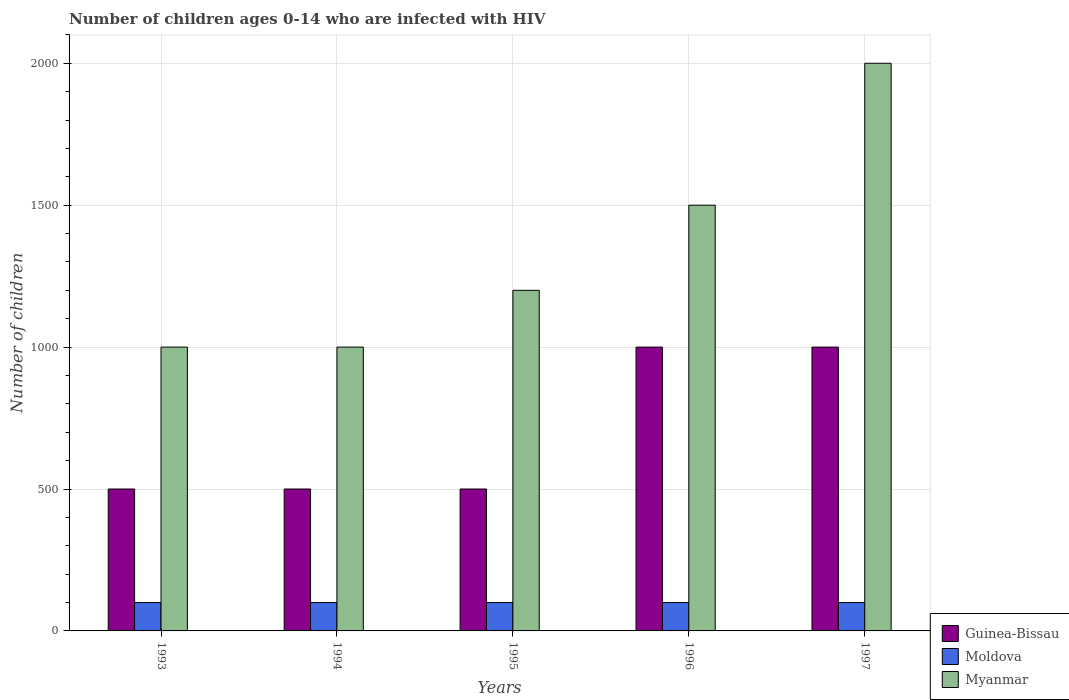How many bars are there on the 2nd tick from the left?
Provide a succinct answer. 3. What is the label of the 5th group of bars from the left?
Your answer should be compact. 1997. What is the number of HIV infected children in Guinea-Bissau in 1994?
Ensure brevity in your answer.  500. Across all years, what is the maximum number of HIV infected children in Moldova?
Offer a terse response. 100. Across all years, what is the minimum number of HIV infected children in Myanmar?
Your answer should be very brief. 1000. In which year was the number of HIV infected children in Moldova minimum?
Offer a very short reply. 1993. What is the total number of HIV infected children in Guinea-Bissau in the graph?
Your response must be concise. 3500. What is the difference between the number of HIV infected children in Myanmar in 1994 and that in 1995?
Provide a succinct answer. -200. What is the difference between the number of HIV infected children in Guinea-Bissau in 1994 and the number of HIV infected children in Moldova in 1995?
Your answer should be very brief. 400. What is the average number of HIV infected children in Guinea-Bissau per year?
Offer a very short reply. 700. In the year 1993, what is the difference between the number of HIV infected children in Myanmar and number of HIV infected children in Moldova?
Your response must be concise. 900. In how many years, is the number of HIV infected children in Guinea-Bissau greater than 1700?
Offer a very short reply. 0. What is the ratio of the number of HIV infected children in Myanmar in 1993 to that in 1995?
Keep it short and to the point. 0.83. Is the difference between the number of HIV infected children in Myanmar in 1995 and 1996 greater than the difference between the number of HIV infected children in Moldova in 1995 and 1996?
Offer a very short reply. No. What is the difference between the highest and the lowest number of HIV infected children in Myanmar?
Your answer should be very brief. 1000. In how many years, is the number of HIV infected children in Myanmar greater than the average number of HIV infected children in Myanmar taken over all years?
Provide a succinct answer. 2. Is the sum of the number of HIV infected children in Guinea-Bissau in 1994 and 1996 greater than the maximum number of HIV infected children in Myanmar across all years?
Offer a very short reply. No. What does the 2nd bar from the left in 1996 represents?
Provide a short and direct response. Moldova. What does the 2nd bar from the right in 1993 represents?
Offer a very short reply. Moldova. How many bars are there?
Your answer should be very brief. 15. Are all the bars in the graph horizontal?
Your answer should be compact. No. Are the values on the major ticks of Y-axis written in scientific E-notation?
Your answer should be very brief. No. Where does the legend appear in the graph?
Offer a terse response. Bottom right. How are the legend labels stacked?
Your response must be concise. Vertical. What is the title of the graph?
Your answer should be compact. Number of children ages 0-14 who are infected with HIV. Does "Liberia" appear as one of the legend labels in the graph?
Keep it short and to the point. No. What is the label or title of the Y-axis?
Ensure brevity in your answer.  Number of children. What is the Number of children of Guinea-Bissau in 1993?
Offer a terse response. 500. What is the Number of children of Myanmar in 1993?
Offer a terse response. 1000. What is the Number of children of Moldova in 1994?
Offer a very short reply. 100. What is the Number of children of Myanmar in 1995?
Provide a short and direct response. 1200. What is the Number of children in Guinea-Bissau in 1996?
Your response must be concise. 1000. What is the Number of children of Moldova in 1996?
Give a very brief answer. 100. What is the Number of children in Myanmar in 1996?
Make the answer very short. 1500. What is the Number of children of Guinea-Bissau in 1997?
Make the answer very short. 1000. What is the Number of children of Myanmar in 1997?
Your response must be concise. 2000. Across all years, what is the maximum Number of children of Guinea-Bissau?
Give a very brief answer. 1000. Across all years, what is the maximum Number of children in Moldova?
Provide a short and direct response. 100. Across all years, what is the maximum Number of children of Myanmar?
Make the answer very short. 2000. What is the total Number of children of Guinea-Bissau in the graph?
Your answer should be compact. 3500. What is the total Number of children in Moldova in the graph?
Ensure brevity in your answer.  500. What is the total Number of children of Myanmar in the graph?
Provide a succinct answer. 6700. What is the difference between the Number of children of Guinea-Bissau in 1993 and that in 1994?
Give a very brief answer. 0. What is the difference between the Number of children of Moldova in 1993 and that in 1994?
Provide a succinct answer. 0. What is the difference between the Number of children of Myanmar in 1993 and that in 1994?
Offer a very short reply. 0. What is the difference between the Number of children of Guinea-Bissau in 1993 and that in 1995?
Ensure brevity in your answer.  0. What is the difference between the Number of children in Moldova in 1993 and that in 1995?
Your answer should be very brief. 0. What is the difference between the Number of children in Myanmar in 1993 and that in 1995?
Your answer should be very brief. -200. What is the difference between the Number of children of Guinea-Bissau in 1993 and that in 1996?
Provide a succinct answer. -500. What is the difference between the Number of children in Myanmar in 1993 and that in 1996?
Offer a terse response. -500. What is the difference between the Number of children in Guinea-Bissau in 1993 and that in 1997?
Offer a terse response. -500. What is the difference between the Number of children of Myanmar in 1993 and that in 1997?
Your response must be concise. -1000. What is the difference between the Number of children of Moldova in 1994 and that in 1995?
Give a very brief answer. 0. What is the difference between the Number of children of Myanmar in 1994 and that in 1995?
Provide a short and direct response. -200. What is the difference between the Number of children of Guinea-Bissau in 1994 and that in 1996?
Make the answer very short. -500. What is the difference between the Number of children of Myanmar in 1994 and that in 1996?
Offer a very short reply. -500. What is the difference between the Number of children in Guinea-Bissau in 1994 and that in 1997?
Provide a short and direct response. -500. What is the difference between the Number of children of Moldova in 1994 and that in 1997?
Your response must be concise. 0. What is the difference between the Number of children of Myanmar in 1994 and that in 1997?
Offer a very short reply. -1000. What is the difference between the Number of children in Guinea-Bissau in 1995 and that in 1996?
Your response must be concise. -500. What is the difference between the Number of children of Myanmar in 1995 and that in 1996?
Make the answer very short. -300. What is the difference between the Number of children in Guinea-Bissau in 1995 and that in 1997?
Provide a short and direct response. -500. What is the difference between the Number of children in Myanmar in 1995 and that in 1997?
Give a very brief answer. -800. What is the difference between the Number of children of Guinea-Bissau in 1996 and that in 1997?
Give a very brief answer. 0. What is the difference between the Number of children of Myanmar in 1996 and that in 1997?
Your answer should be compact. -500. What is the difference between the Number of children in Guinea-Bissau in 1993 and the Number of children in Moldova in 1994?
Ensure brevity in your answer.  400. What is the difference between the Number of children in Guinea-Bissau in 1993 and the Number of children in Myanmar in 1994?
Provide a short and direct response. -500. What is the difference between the Number of children of Moldova in 1993 and the Number of children of Myanmar in 1994?
Your answer should be very brief. -900. What is the difference between the Number of children in Guinea-Bissau in 1993 and the Number of children in Myanmar in 1995?
Provide a succinct answer. -700. What is the difference between the Number of children in Moldova in 1993 and the Number of children in Myanmar in 1995?
Ensure brevity in your answer.  -1100. What is the difference between the Number of children of Guinea-Bissau in 1993 and the Number of children of Moldova in 1996?
Provide a succinct answer. 400. What is the difference between the Number of children in Guinea-Bissau in 1993 and the Number of children in Myanmar in 1996?
Provide a succinct answer. -1000. What is the difference between the Number of children of Moldova in 1993 and the Number of children of Myanmar in 1996?
Your answer should be very brief. -1400. What is the difference between the Number of children of Guinea-Bissau in 1993 and the Number of children of Moldova in 1997?
Keep it short and to the point. 400. What is the difference between the Number of children of Guinea-Bissau in 1993 and the Number of children of Myanmar in 1997?
Your answer should be very brief. -1500. What is the difference between the Number of children in Moldova in 1993 and the Number of children in Myanmar in 1997?
Your response must be concise. -1900. What is the difference between the Number of children in Guinea-Bissau in 1994 and the Number of children in Moldova in 1995?
Keep it short and to the point. 400. What is the difference between the Number of children in Guinea-Bissau in 1994 and the Number of children in Myanmar in 1995?
Provide a short and direct response. -700. What is the difference between the Number of children of Moldova in 1994 and the Number of children of Myanmar in 1995?
Your answer should be compact. -1100. What is the difference between the Number of children in Guinea-Bissau in 1994 and the Number of children in Myanmar in 1996?
Offer a very short reply. -1000. What is the difference between the Number of children of Moldova in 1994 and the Number of children of Myanmar in 1996?
Provide a succinct answer. -1400. What is the difference between the Number of children in Guinea-Bissau in 1994 and the Number of children in Myanmar in 1997?
Your response must be concise. -1500. What is the difference between the Number of children of Moldova in 1994 and the Number of children of Myanmar in 1997?
Make the answer very short. -1900. What is the difference between the Number of children of Guinea-Bissau in 1995 and the Number of children of Moldova in 1996?
Provide a short and direct response. 400. What is the difference between the Number of children in Guinea-Bissau in 1995 and the Number of children in Myanmar in 1996?
Your answer should be very brief. -1000. What is the difference between the Number of children in Moldova in 1995 and the Number of children in Myanmar in 1996?
Make the answer very short. -1400. What is the difference between the Number of children in Guinea-Bissau in 1995 and the Number of children in Moldova in 1997?
Provide a succinct answer. 400. What is the difference between the Number of children of Guinea-Bissau in 1995 and the Number of children of Myanmar in 1997?
Give a very brief answer. -1500. What is the difference between the Number of children in Moldova in 1995 and the Number of children in Myanmar in 1997?
Provide a succinct answer. -1900. What is the difference between the Number of children of Guinea-Bissau in 1996 and the Number of children of Moldova in 1997?
Your response must be concise. 900. What is the difference between the Number of children of Guinea-Bissau in 1996 and the Number of children of Myanmar in 1997?
Make the answer very short. -1000. What is the difference between the Number of children of Moldova in 1996 and the Number of children of Myanmar in 1997?
Make the answer very short. -1900. What is the average Number of children of Guinea-Bissau per year?
Your response must be concise. 700. What is the average Number of children of Moldova per year?
Provide a short and direct response. 100. What is the average Number of children in Myanmar per year?
Ensure brevity in your answer.  1340. In the year 1993, what is the difference between the Number of children of Guinea-Bissau and Number of children of Moldova?
Your answer should be compact. 400. In the year 1993, what is the difference between the Number of children in Guinea-Bissau and Number of children in Myanmar?
Offer a very short reply. -500. In the year 1993, what is the difference between the Number of children of Moldova and Number of children of Myanmar?
Keep it short and to the point. -900. In the year 1994, what is the difference between the Number of children in Guinea-Bissau and Number of children in Moldova?
Ensure brevity in your answer.  400. In the year 1994, what is the difference between the Number of children of Guinea-Bissau and Number of children of Myanmar?
Your response must be concise. -500. In the year 1994, what is the difference between the Number of children in Moldova and Number of children in Myanmar?
Your response must be concise. -900. In the year 1995, what is the difference between the Number of children in Guinea-Bissau and Number of children in Myanmar?
Provide a short and direct response. -700. In the year 1995, what is the difference between the Number of children of Moldova and Number of children of Myanmar?
Make the answer very short. -1100. In the year 1996, what is the difference between the Number of children in Guinea-Bissau and Number of children in Moldova?
Your answer should be very brief. 900. In the year 1996, what is the difference between the Number of children in Guinea-Bissau and Number of children in Myanmar?
Offer a terse response. -500. In the year 1996, what is the difference between the Number of children in Moldova and Number of children in Myanmar?
Ensure brevity in your answer.  -1400. In the year 1997, what is the difference between the Number of children in Guinea-Bissau and Number of children in Moldova?
Your answer should be very brief. 900. In the year 1997, what is the difference between the Number of children of Guinea-Bissau and Number of children of Myanmar?
Your answer should be compact. -1000. In the year 1997, what is the difference between the Number of children in Moldova and Number of children in Myanmar?
Keep it short and to the point. -1900. What is the ratio of the Number of children of Myanmar in 1993 to that in 1994?
Your answer should be compact. 1. What is the ratio of the Number of children of Myanmar in 1993 to that in 1995?
Provide a succinct answer. 0.83. What is the ratio of the Number of children in Guinea-Bissau in 1993 to that in 1996?
Your response must be concise. 0.5. What is the ratio of the Number of children of Myanmar in 1993 to that in 1996?
Provide a short and direct response. 0.67. What is the ratio of the Number of children of Myanmar in 1993 to that in 1997?
Ensure brevity in your answer.  0.5. What is the ratio of the Number of children of Guinea-Bissau in 1994 to that in 1995?
Offer a very short reply. 1. What is the ratio of the Number of children in Moldova in 1994 to that in 1995?
Your response must be concise. 1. What is the ratio of the Number of children of Myanmar in 1994 to that in 1995?
Give a very brief answer. 0.83. What is the ratio of the Number of children in Guinea-Bissau in 1994 to that in 1996?
Make the answer very short. 0.5. What is the ratio of the Number of children of Moldova in 1994 to that in 1996?
Provide a short and direct response. 1. What is the ratio of the Number of children in Myanmar in 1994 to that in 1997?
Your answer should be compact. 0.5. What is the ratio of the Number of children of Guinea-Bissau in 1995 to that in 1996?
Ensure brevity in your answer.  0.5. What is the ratio of the Number of children in Moldova in 1995 to that in 1996?
Offer a terse response. 1. What is the ratio of the Number of children in Guinea-Bissau in 1995 to that in 1997?
Make the answer very short. 0.5. What is the ratio of the Number of children in Guinea-Bissau in 1996 to that in 1997?
Keep it short and to the point. 1. What is the ratio of the Number of children in Moldova in 1996 to that in 1997?
Your response must be concise. 1. What is the difference between the highest and the second highest Number of children in Moldova?
Offer a terse response. 0. What is the difference between the highest and the lowest Number of children in Guinea-Bissau?
Your answer should be compact. 500. What is the difference between the highest and the lowest Number of children of Moldova?
Give a very brief answer. 0. What is the difference between the highest and the lowest Number of children of Myanmar?
Ensure brevity in your answer.  1000. 